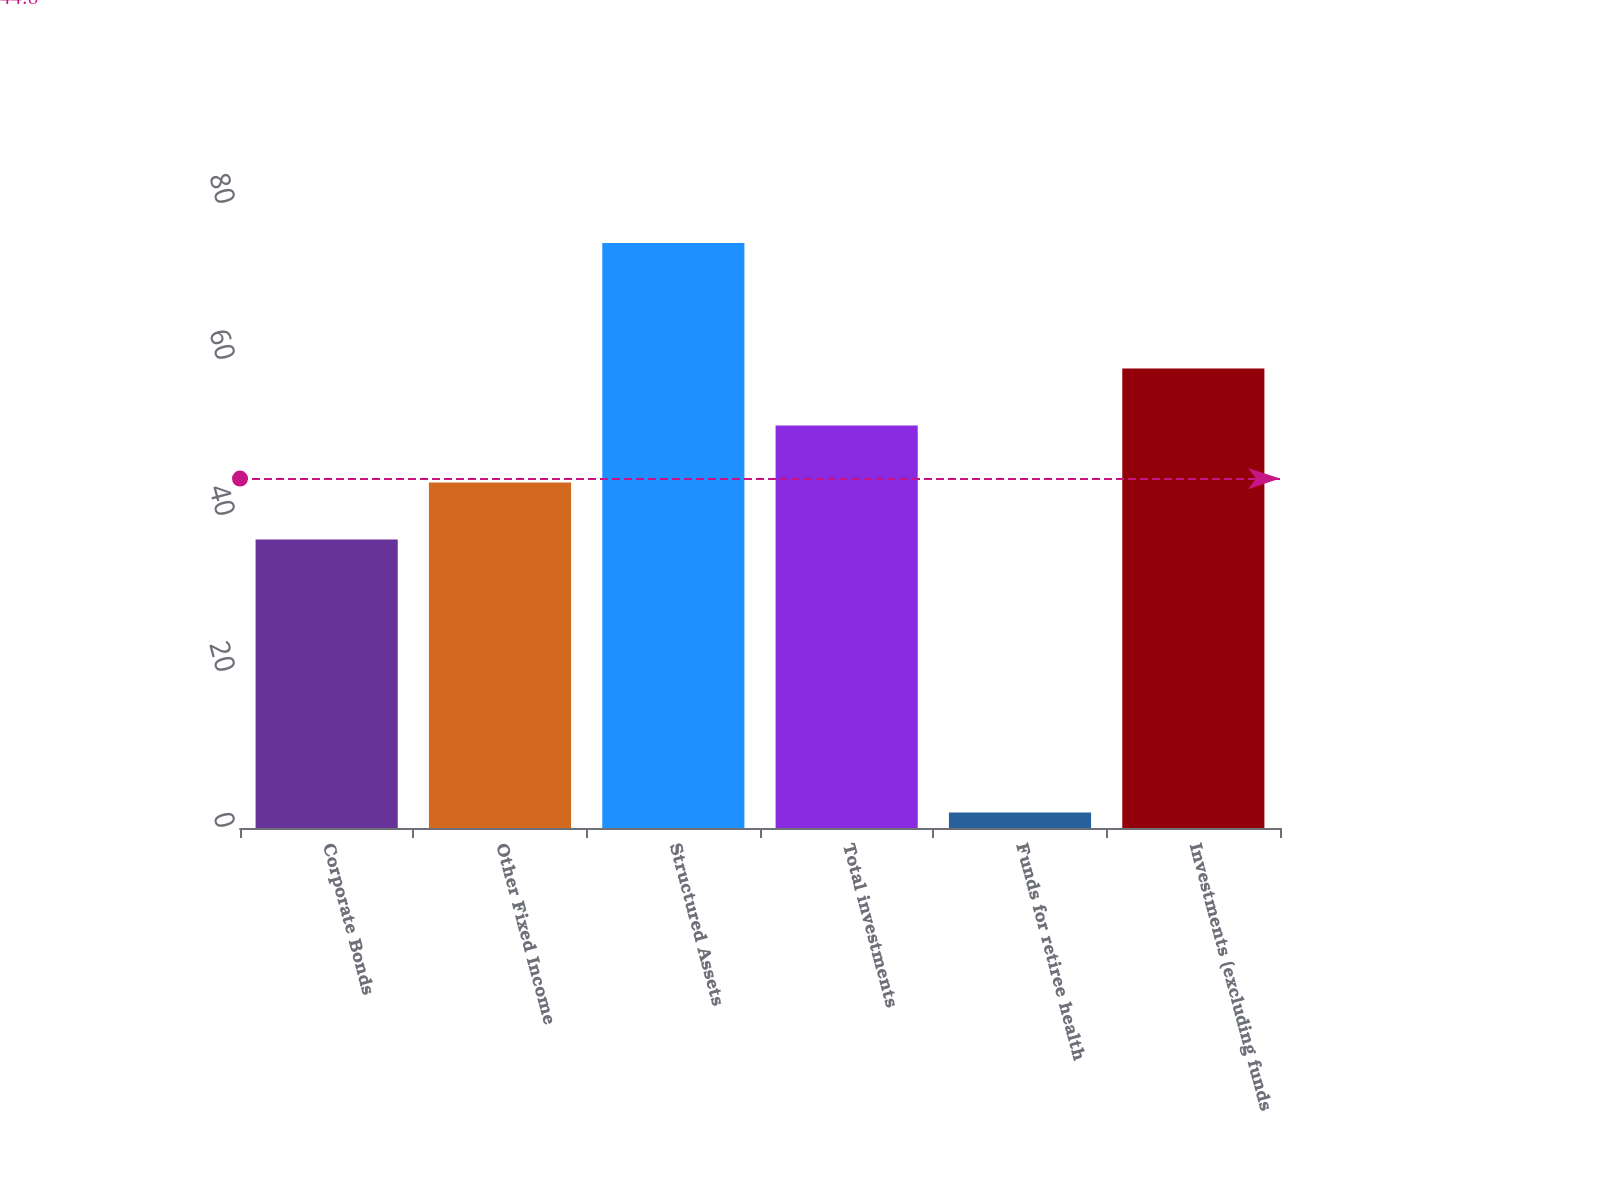<chart> <loc_0><loc_0><loc_500><loc_500><bar_chart><fcel>Corporate Bonds<fcel>Other Fixed Income<fcel>Structured Assets<fcel>Total investments<fcel>Funds for retiree health<fcel>Investments (excluding funds<nl><fcel>37<fcel>44.3<fcel>75<fcel>51.6<fcel>2<fcel>58.9<nl></chart> 